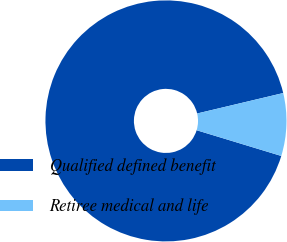<chart> <loc_0><loc_0><loc_500><loc_500><pie_chart><fcel>Qualified defined benefit<fcel>Retiree medical and life<nl><fcel>91.59%<fcel>8.41%<nl></chart> 